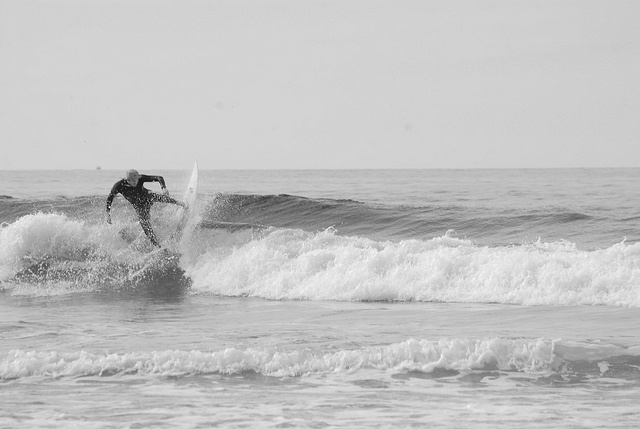Describe the objects in this image and their specific colors. I can see people in lightgray, black, gray, and darkgray tones, surfboard in lightgray, darkgray, and gray tones, and boat in lightgray, darkgray, and black tones in this image. 